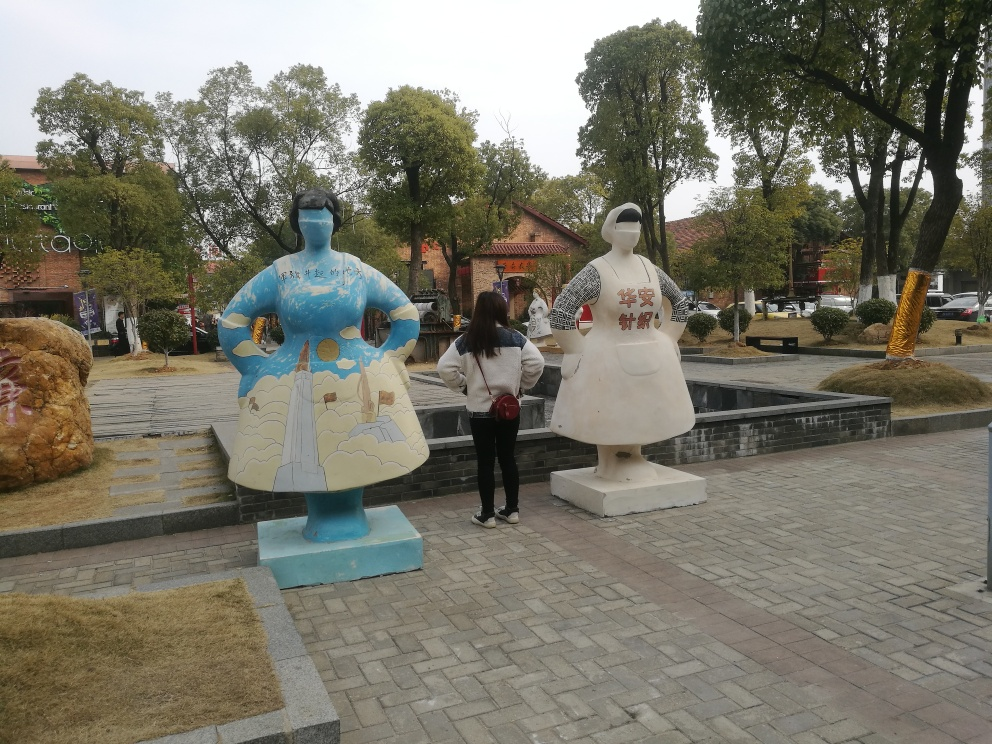Can you tell me more about the setting where these statues are located? The setting appears to be a public space, potentially a park or square, given the presence of pedestrian pathways, greenery, and what looks like seating areas. The environment is designed for accessibility and recreation, possibly situated in an urban area where such artistic displays are integrated into public life. It blends artistic elements with functional urban design, offering a place for both contemplation and social interaction. Do you think this is a special event or a permanent installation? Without additional context, it's challenging to determine with certainty whether this is a special event or a permanent installation. However, the statues seem to be mounted on solid bases, which suggests they could be a long-term feature of this space. Additionally, the lack of temporary structures or signs that usually accompany events leads me to lean towards them being a permanent or semi-permanent installation meant to enrich the environment on an ongoing basis. 